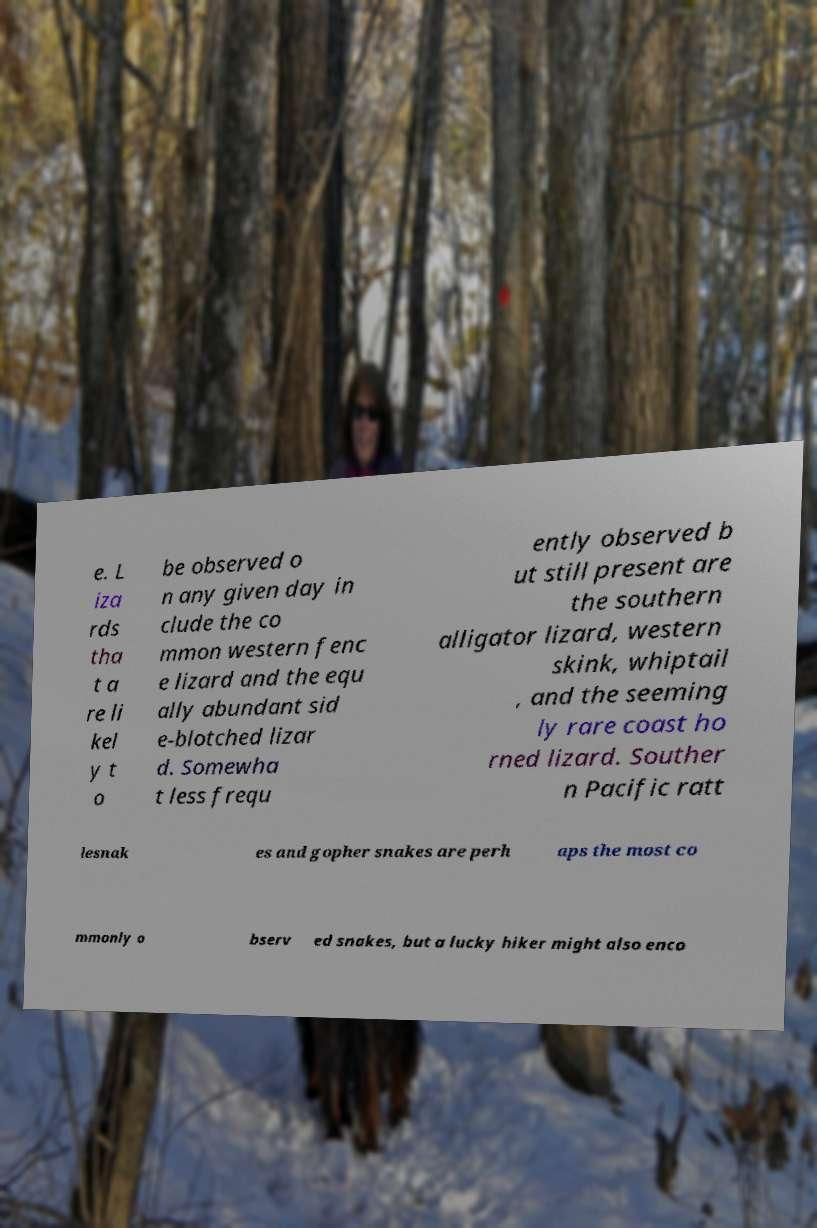Could you extract and type out the text from this image? e. L iza rds tha t a re li kel y t o be observed o n any given day in clude the co mmon western fenc e lizard and the equ ally abundant sid e-blotched lizar d. Somewha t less frequ ently observed b ut still present are the southern alligator lizard, western skink, whiptail , and the seeming ly rare coast ho rned lizard. Souther n Pacific ratt lesnak es and gopher snakes are perh aps the most co mmonly o bserv ed snakes, but a lucky hiker might also enco 